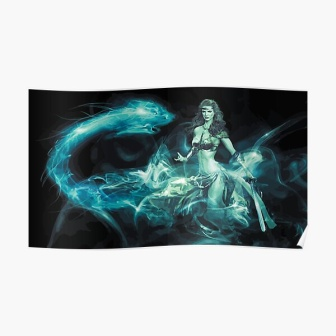Imagine a story where this woman is the central character. In a land shrouded in perpetual twilight, where ancient spirits roamed and the boundary between the living and the ethereal was thin, she stood as the last guardian. Known as Seraphina, the Lady of the Mist, she held the spirit blade—a relic passed down through generations meant to protect the realm from encroaching darkness.

Seraphina's journey was one of solitude and sacrifice. She wandered through haunted forests and desolate wastes, guided by the ever-present blue smoke—a manifestation of her ancestors' spirits. Each day, she faced trials that tested her strength and resolve, but her purpose was clear; she was the shield against the shadows that sought to engulf her world. What challenges might Seraphina face on her journey? Seraphina encountered formidable foes on her journey. Great shadow beasts with eyes like burning coals lurked in the dark corners of ancient ruins, guarding hidden relics and forbidden knowledge. Sorcerers, long thought exiled, emerged from their hidden sanctuaries, wielding forbidden magic that twisted reality itself. Nature itself seemed to rebel against her—forests moved to block her path, rivers flooded suddenly, and the sky wept torrential storms without warning.

Yet, her greatest challenge lay within. As the keeper of the spirit blade, Seraphina was burdened with the memories and emotions of all those who had wielded it before her. Their triumphs and failures, their joys and sorrows, all weighed heavily within, threatening to overwhelm her. It was a test of strength, not just physical, but of spirit and will. Visualize a climactic battle that Seraphina faces. Amongst swirling mists atop the highest peak known as the Spire of Souls, the climactic battle unfolded. The very air around Seraphina crackled with anticipation as she confronted the Shadow Sovereign, the ancient entity of darkness that had tormented her land for centuries. Its form was amorphous, a swirling mass of darkness with glowing eyes that pierced through the soul.

With her spirit blade gleaming in her hand, Seraphina called upon the spirits of her ancestors. The blue smoke that had always accompanied her now roared to life, forming spectral figures of past guardians who had faced similar threats. The ground trembled and the skies erupted with lightning as the final battle commenced.

Blow after blow, Seraphina fought valiantly amidst a storm of shadows and light. The two forces collided with unimaginable power, each strike sending shockwaves through the realm. Her movements were a blur of determination and grace as she countered the Shadow Sovereign's every assault, the blue tendrils moving in perfect harmony with her.  Imagine a creative element that enhances the mystical nature of the image. What if the blue smoke surrounding Seraphina was actually a collection of enchanted spirits, each with its own personality and power? These spirits could communicate with her, offering guidance, sharing their wisdom, and even intervening in her battles, making the smoke not just an effect, but an integral part of her character and story. 